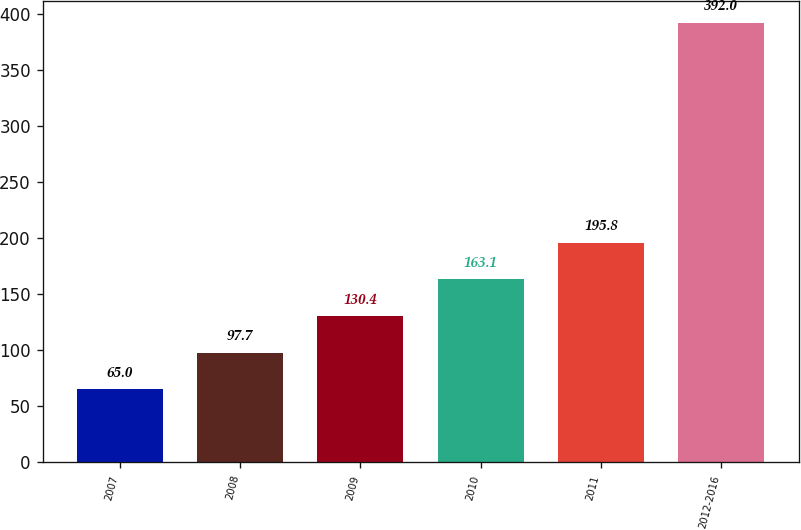Convert chart to OTSL. <chart><loc_0><loc_0><loc_500><loc_500><bar_chart><fcel>2007<fcel>2008<fcel>2009<fcel>2010<fcel>2011<fcel>2012-2016<nl><fcel>65<fcel>97.7<fcel>130.4<fcel>163.1<fcel>195.8<fcel>392<nl></chart> 